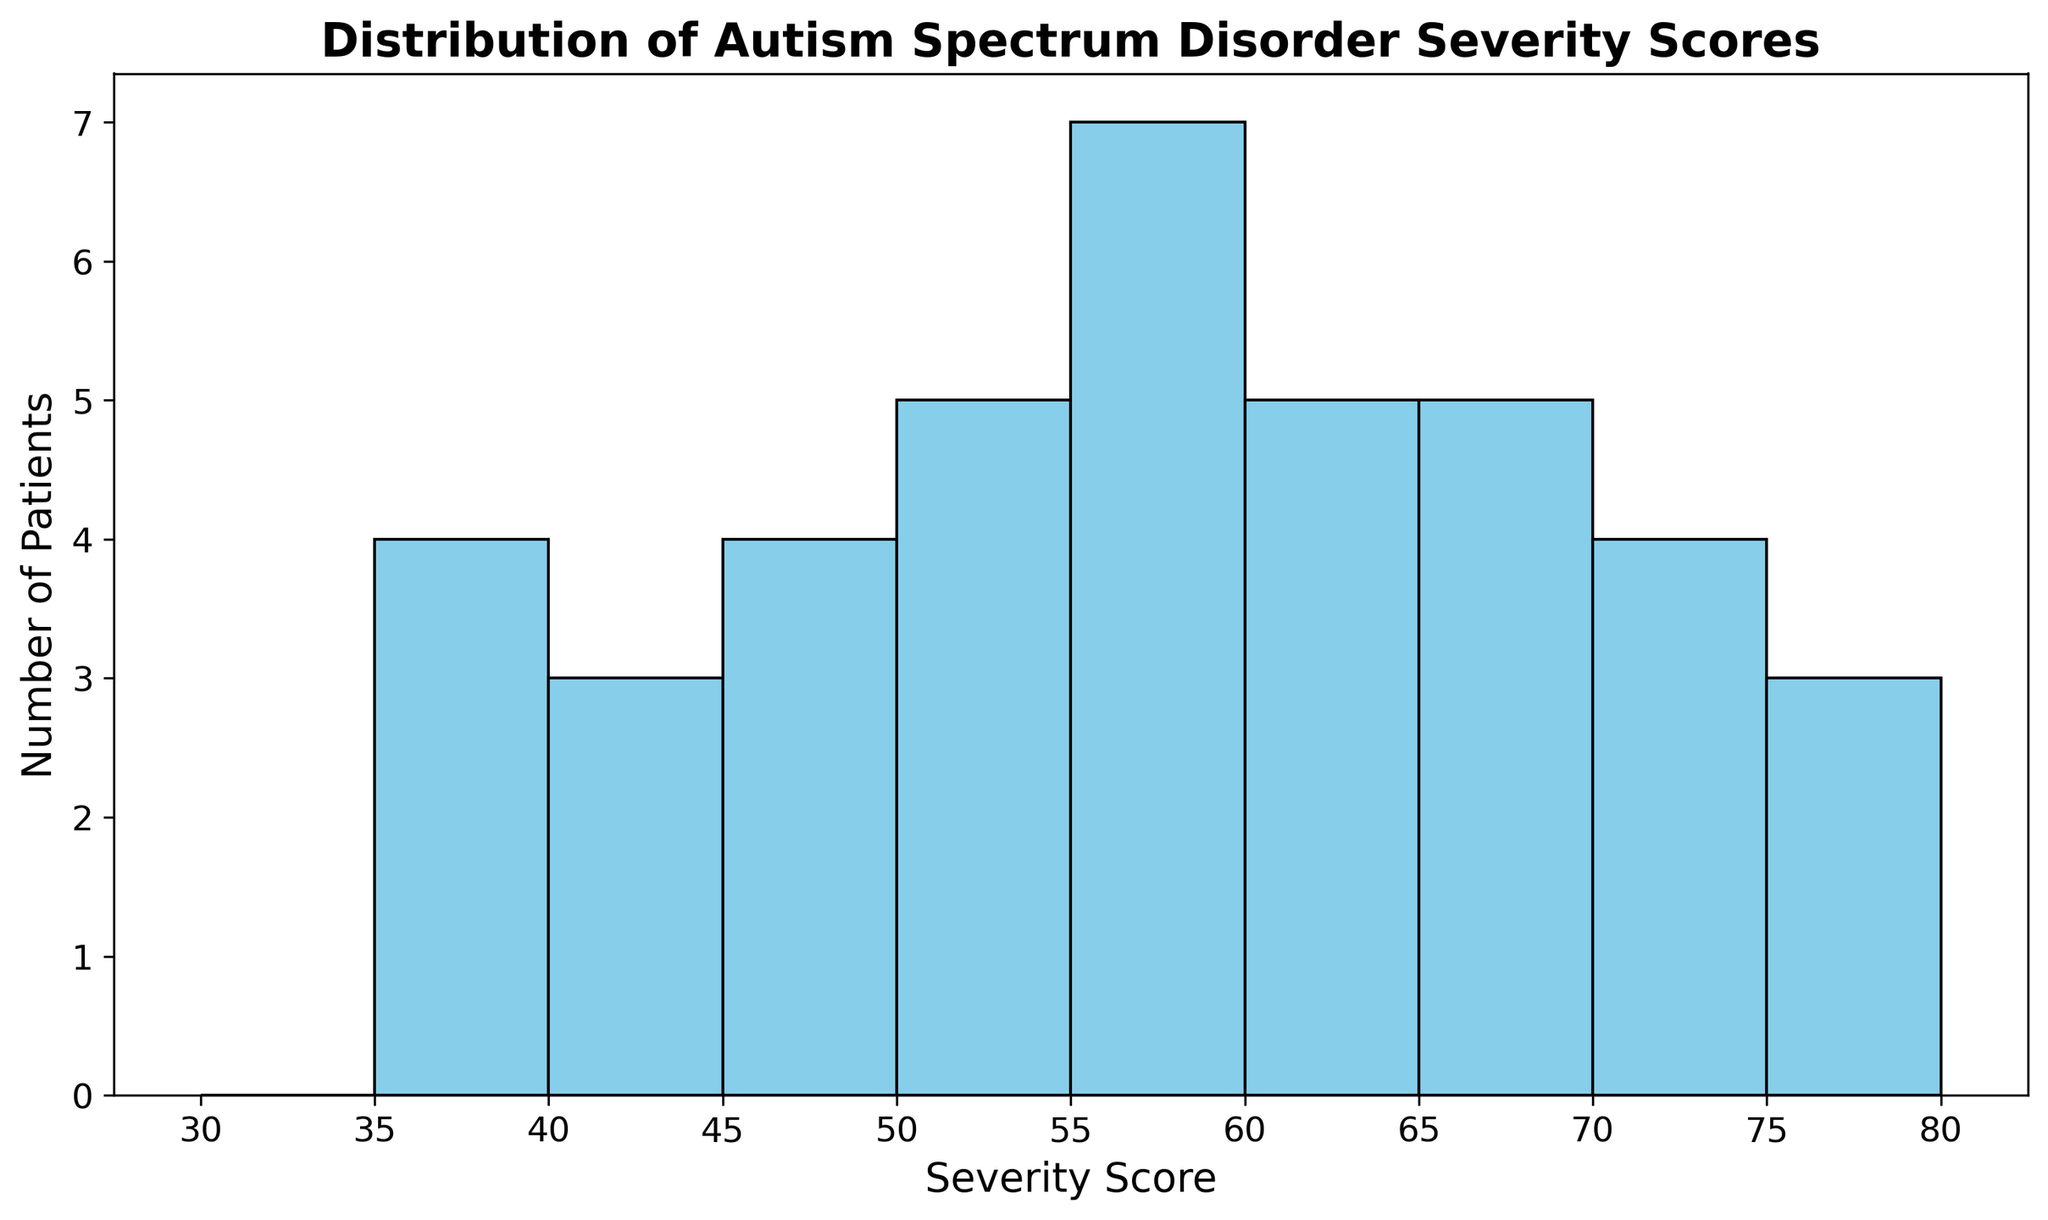What's the range of the severity scores shown in the histogram? The histogram displays severity scores from the lowest score to the highest. The bins range from 30 to 80. Therefore, the range is from the lowest bin (30-35) to the highest bin (75-80).
Answer: 30-75 Which severity score bin contains the highest number of patients? By observing the heights of the bars in the histogram, the bin corresponding to 55-60 has the highest bar, indicating it contains the highest number of patients.
Answer: 55-60 How many bins have more than 5 patients? Visually count the number of bins where the bars exceed the height corresponding to 5 patients. The bins 55-60, 60-65, and 65-70 each have bars taller than the height for 5 patients. This gives a total of 3 bins.
Answer: 3 What is the total number of patients with severity scores between 45 and 60? Identify the bins that fall within this range (45-50, 50-55, 55-60), and sum the values. Each of these bins has more than one bar unit tall (height showing number of patients). From the histogram, add the values: (Count in 45-50) + (Count in 50-55) + (Count in 55-60).
Answer: 21 Which score range has the fewest patients? Find the shortest bar(s) in the histogram. The bins corresponding to 30-35 and 35-40 each are the shortest and represent the lower severity score ranges. Therefore, these have the fewest patients.
Answer: 30-35, 35-40 Is there a symmetrical distribution of autism severity scores? Symmetry in a histogram would mean the bars on either side of the central score have similar heights. Observing the histogram, the distribution does not look symmetrical since the number of patients increases around the middle bins and decreases unevenly towards the edges.
Answer: No How many total bins are there in the histogram? Count the number of bins depicted in the histogram. Each bar spanning a range interval indicates a bin. According to the histogram, the bins are: 30-35, 35-40, 40-45, 45-50, 50-55, 55-60, 60-65, 65-70, 70-75.
Answer: 9 What is the average number of patients per bin? To find the average, divide the total number of patients by the number of bins. Total patients are 40, and there are 9 bins. So, 40/9 = approximately 4.44 patients per bin.
Answer: 4.44 